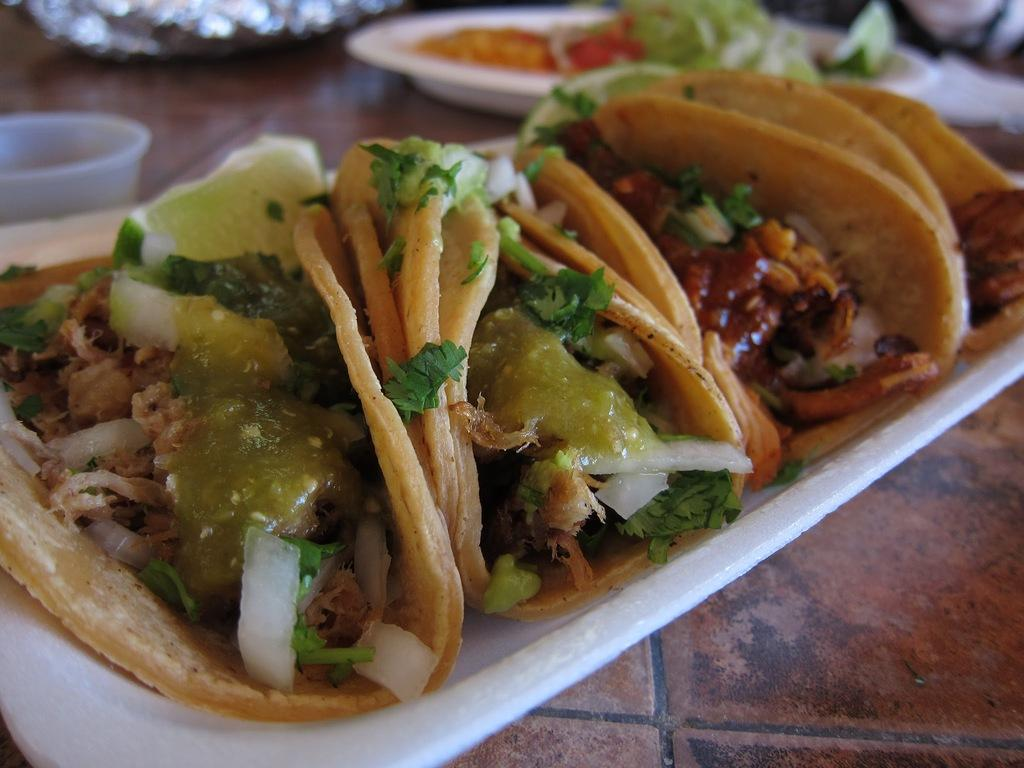What type of food is on the plate in the image? There is a plate with tacos in the image. Are there any other plates with food in the image? Yes, there is another plate with food in the image. What type of container is on the table in the image? There is a plastic bowl on the table in the image. Can you see any monkeys in the wilderness in the image? There is no mention of monkeys or wilderness in the image; it features a plate with tacos, another plate with food, and a plastic bowl on the table. 